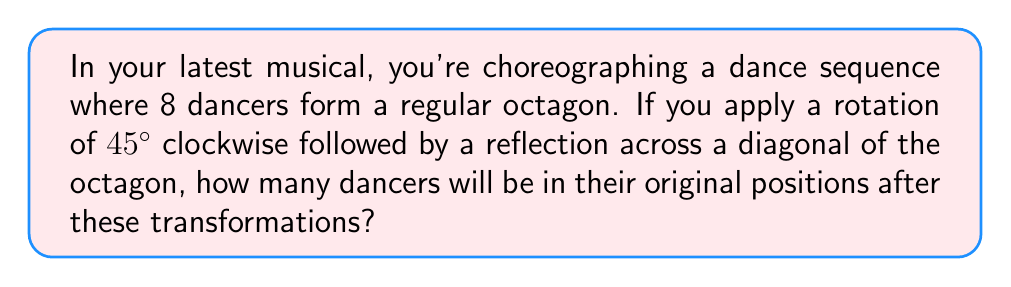Can you answer this question? Let's approach this step-by-step:

1) First, we need to understand the symmetries of a regular octagon:
   - It has 8 rotational symmetries (including the identity)
   - It has 8 reflection symmetries (4 through vertices and 4 through midpoints of sides)

2) The transformations given are:
   a) Rotation of 45° clockwise
   b) Reflection across a diagonal

3) Let's analyze the rotation:
   - A 45° rotation clockwise moves each dancer one position in the clockwise direction.
   - This can be represented as the permutation $(1 2 3 4 5 6 7 8)$ in cycle notation.

4) Now, let's consider the reflection:
   - A reflection across a diagonal swaps pairs of dancers.
   - This can be represented as $(1 8)(2 7)(3 6)(4 5)$ in cycle notation.

5) To find the combined effect, we compose these transformations:
   $$(1 8)(2 7)(3 6)(4 5) \circ (1 2 3 4 5 6 7 8)$$

6) Working this out:
   1 → 2 → 7
   2 → 3 → 6
   3 → 4 → 5
   4 → 5 → 4
   5 → 6 → 3
   6 → 7 → 2
   7 → 8 → 1
   8 → 1 → 8

7) In cycle notation, this is $(1 7 2 6 3 5 4)(8)$

8) The fixed points (dancers in their original positions) are those in 1-cycles.
   Here, only 8 is in a 1-cycle.

Therefore, only 1 dancer will be in their original position after these transformations.
Answer: 1 